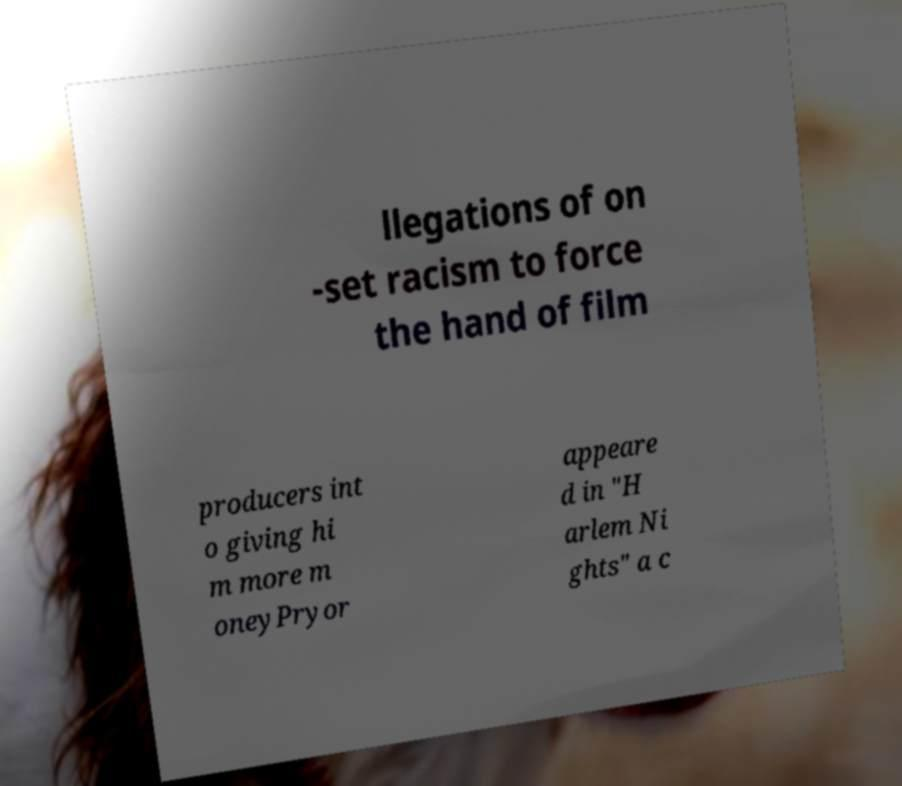Please identify and transcribe the text found in this image. llegations of on -set racism to force the hand of film producers int o giving hi m more m oneyPryor appeare d in "H arlem Ni ghts" a c 